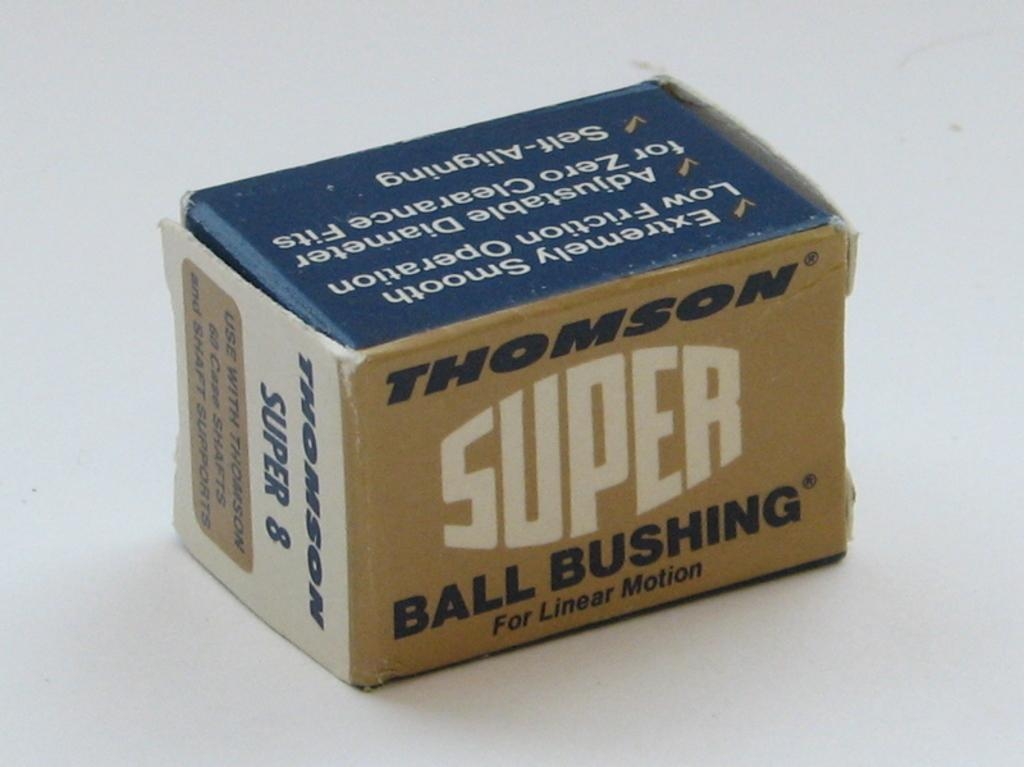What object is the main focus of the image? There is a box in the image. Can you describe the surface on which the box is placed? The box is placed on a white surface. What type of fuel is stored inside the box in the image? There is no indication of any fuel being stored inside the box in the image. 